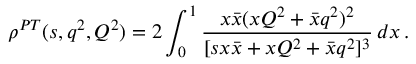Convert formula to latex. <formula><loc_0><loc_0><loc_500><loc_500>\rho ^ { P T } ( s , q ^ { 2 } , Q ^ { 2 } ) = 2 \int _ { 0 } ^ { 1 } \frac { x \bar { x } ( x Q ^ { 2 } + \bar { x } q ^ { 2 } ) ^ { 2 } } { [ s { x } \bar { x } + x Q ^ { 2 } + \bar { x } q ^ { 2 } ] ^ { 3 } } \, d x \, .</formula> 